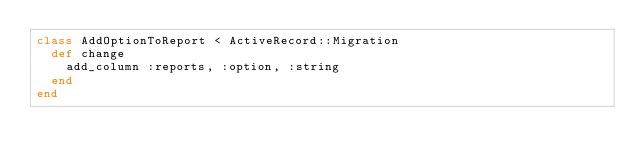Convert code to text. <code><loc_0><loc_0><loc_500><loc_500><_Ruby_>class AddOptionToReport < ActiveRecord::Migration
  def change
    add_column :reports, :option, :string
  end
end
</code> 